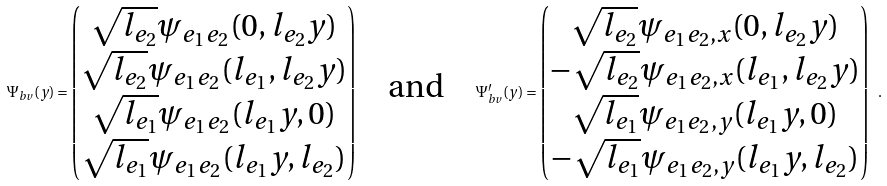<formula> <loc_0><loc_0><loc_500><loc_500>\Psi _ { b v } ( y ) = \begin{pmatrix} \sqrt { l _ { e _ { 2 } } } \psi _ { e _ { 1 } e _ { 2 } } ( 0 , l _ { e _ { 2 } } y ) \\ \sqrt { l _ { e _ { 2 } } } \psi _ { e _ { 1 } e _ { 2 } } ( l _ { e _ { 1 } } , l _ { e _ { 2 } } y ) \\ \sqrt { l _ { e _ { 1 } } } \psi _ { e _ { 1 } e _ { 2 } } ( l _ { e _ { 1 } } y , 0 ) \\ \sqrt { l _ { e _ { 1 } } } \psi _ { e _ { 1 } e _ { 2 } } ( l _ { e _ { 1 } } y , l _ { e _ { 2 } } ) \end{pmatrix} \quad \text {and} \quad \Psi ^ { \prime } _ { b v } ( y ) = \begin{pmatrix} \sqrt { l _ { e _ { 2 } } } \psi _ { e _ { 1 } e _ { 2 } , x } ( 0 , l _ { e _ { 2 } } y ) \\ - \sqrt { l _ { e _ { 2 } } } \psi _ { e _ { 1 } e _ { 2 } , x } ( l _ { e _ { 1 } } , l _ { e _ { 2 } } y ) \\ \sqrt { l _ { e _ { 1 } } } \psi _ { e _ { 1 } e _ { 2 } , y } ( l _ { e _ { 1 } } y , 0 ) \\ - \sqrt { l _ { e _ { 1 } } } \psi _ { e _ { 1 } e _ { 2 } , y } ( l _ { e _ { 1 } } y , l _ { e _ { 2 } } ) \end{pmatrix} \ .</formula> 